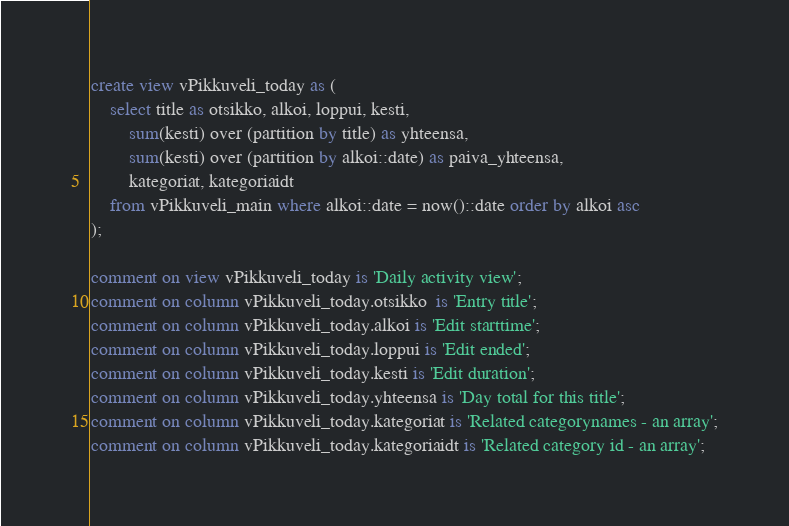<code> <loc_0><loc_0><loc_500><loc_500><_SQL_>create view vPikkuveli_today as (
    select title as otsikko, alkoi, loppui, kesti, 
        sum(kesti) over (partition by title) as yhteensa, 
        sum(kesti) over (partition by alkoi::date) as paiva_yhteensa,
        kategoriat, kategoriaidt  
    from vPikkuveli_main where alkoi::date = now()::date order by alkoi asc
);

comment on view vPikkuveli_today is 'Daily activity view';
comment on column vPikkuveli_today.otsikko  is 'Entry title';
comment on column vPikkuveli_today.alkoi is 'Edit starttime';
comment on column vPikkuveli_today.loppui is 'Edit ended';
comment on column vPikkuveli_today.kesti is 'Edit duration';
comment on column vPikkuveli_today.yhteensa is 'Day total for this title';
comment on column vPikkuveli_today.kategoriat is 'Related categorynames - an array';
comment on column vPikkuveli_today.kategoriaidt is 'Related category id - an array';

</code> 